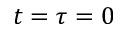Convert formula to latex. <formula><loc_0><loc_0><loc_500><loc_500>t = \tau = 0</formula> 